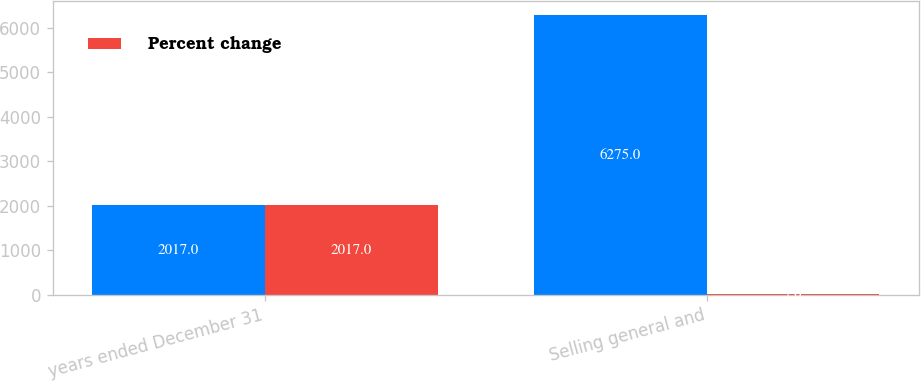<chart> <loc_0><loc_0><loc_500><loc_500><stacked_bar_chart><ecel><fcel>years ended December 31<fcel>Selling general and<nl><fcel>nan<fcel>2017<fcel>6275<nl><fcel>Percent change<fcel>2017<fcel>7<nl></chart> 